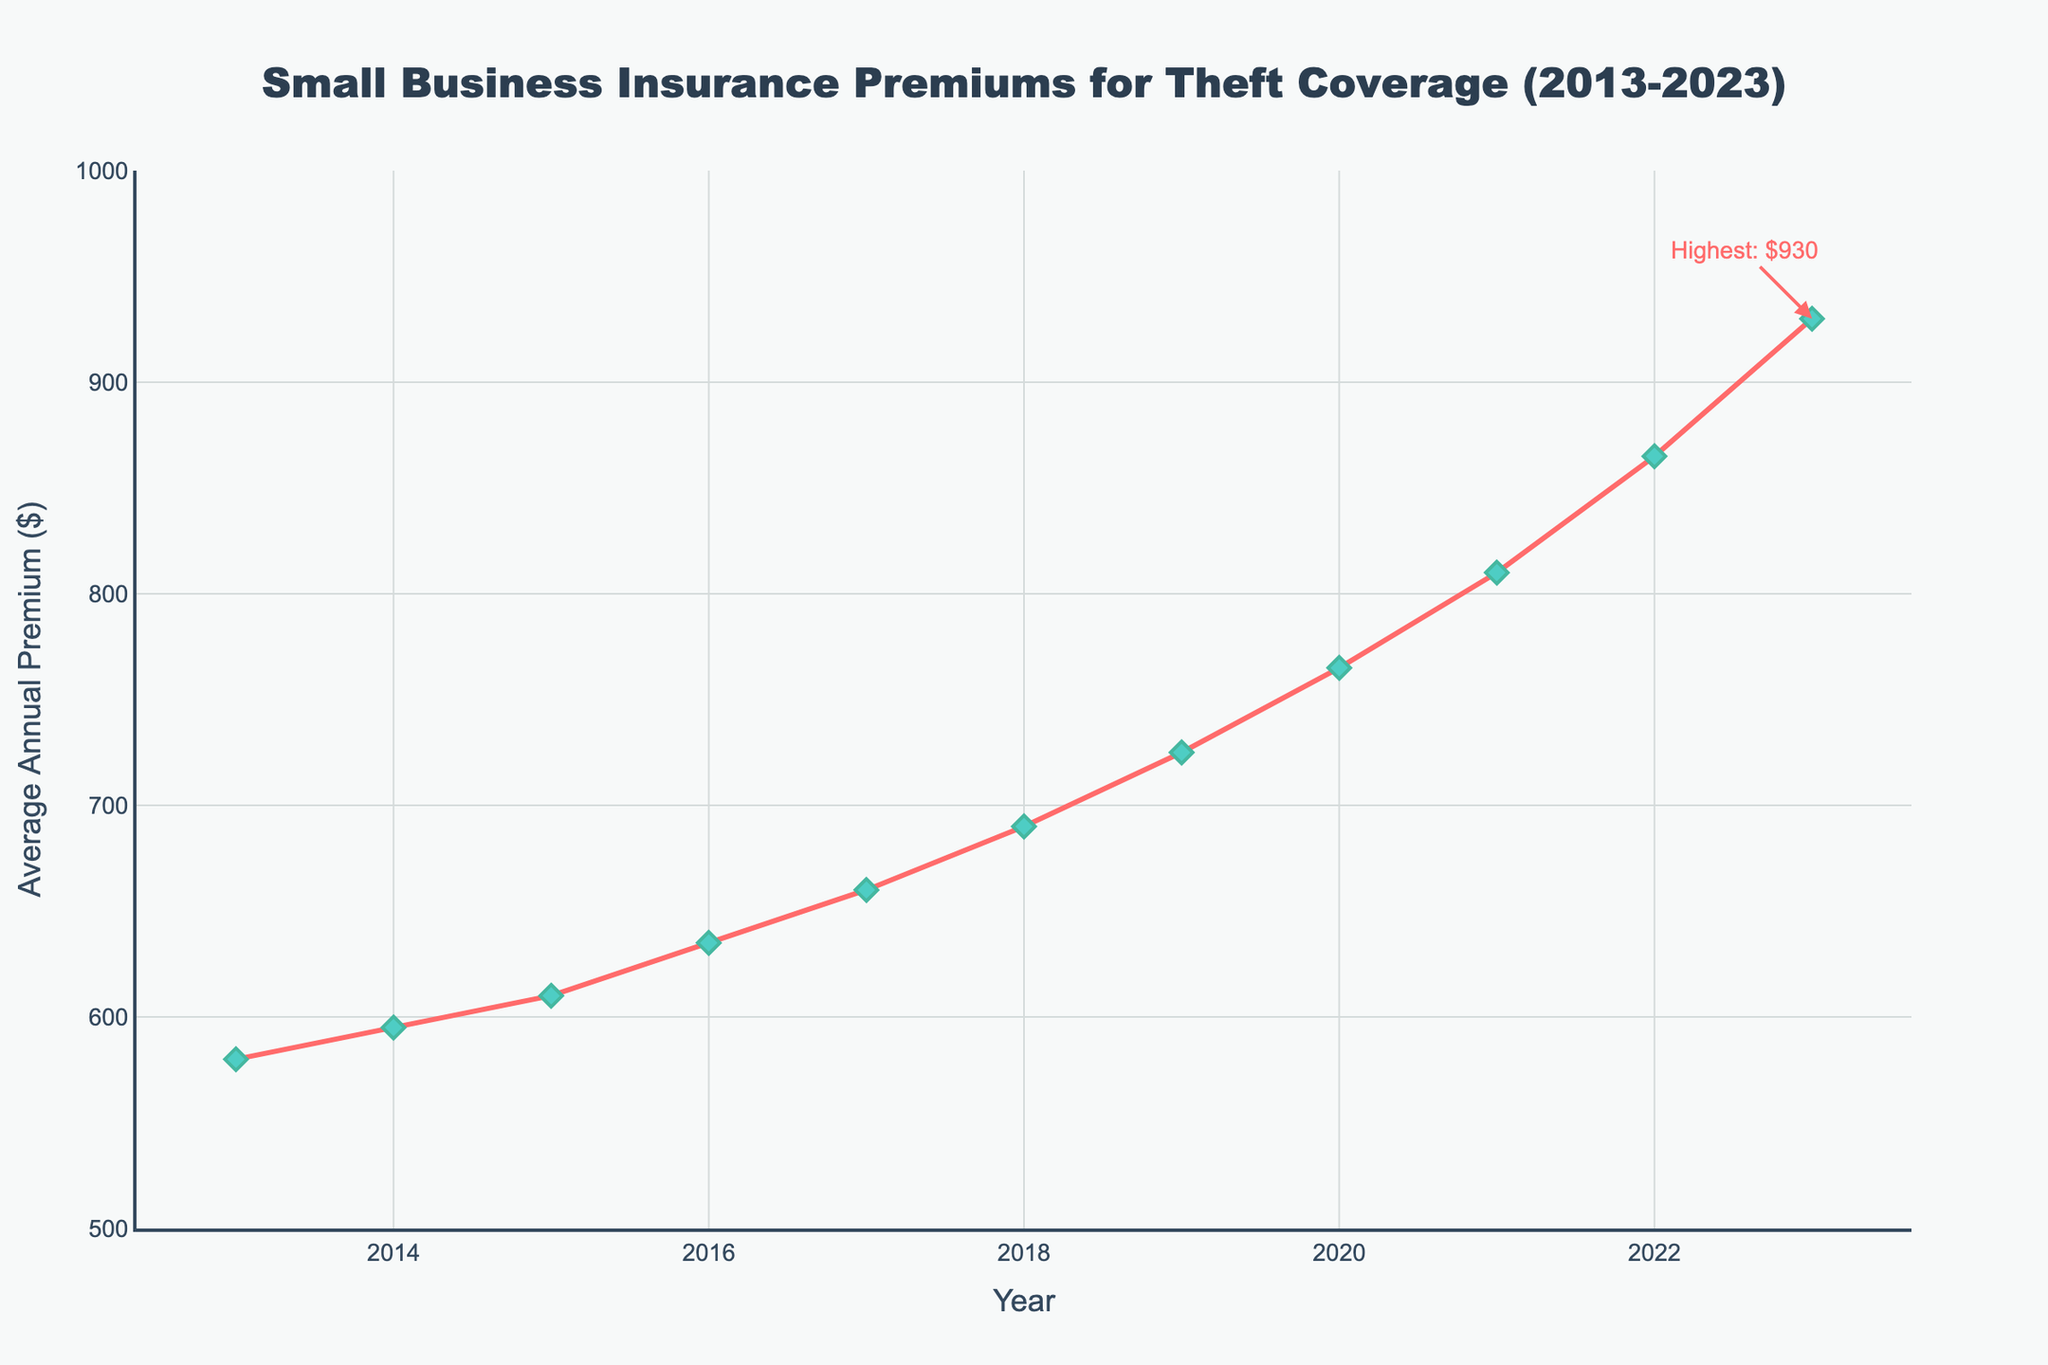What is the trend in the average annual premium for theft coverage over the last decade? Look at the overall pattern of the line from 2013 to 2023. The line rises consistently each year, showing an increasing trend in the average annual premium for theft coverage.
Answer: Increasing Which year had the highest average annual premium for theft coverage? Look at the end of the line chart and locate the highest point, marked with "Highest: $930." This point corresponds to the year 2023.
Answer: 2023 How much did the average annual premium increase from 2013 to 2023? Find the premium value for 2013 ($580) and for 2023 ($930), then subtract the 2013 value from the 2023 value. 930 - 580 = 350.
Answer: $350 Between which consecutive years did the average annual premium for theft coverage increase the most? Look at the gaps between consecutive points along the line and note that the largest increase occurs between 2022 ($865) and 2023 ($930). The difference is 930 - 865 = 65.
Answer: 2022-2023 What is the average annual premium for the year 2019? Identify the point on the line for the year 2019 and read its value, which is $725.
Answer: $725 Has there been any year where the premium did not increase compared to the previous year? Scan each point and note the value of the premium. Each consecutive year shows an increase compared to the previous year.
Answer: No By how much did the average annual premium increase from 2018 to 2019? Locate the premium values for 2018 ($690) and 2019 ($725), then subtract the 2018 value from the 2019 value. 725 - 690 = 35.
Answer: $35 Which year experienced a $55 increase in the average annual premium? Check each pair of consecutive years and find where the premium increased by $55. This happens between 2021 ($810) and 2022 ($865).
Answer: 2021-2022 What color are the data points on the line chart? Observe the color of the markers on the line. They are described as green in the code, which translates to their visual appearance.
Answer: Green In which years did the average annual premium exceed $700 for the first time? Locate the points on the line and note that the premium first exceeds $700 in 2019, where the value is $725.
Answer: 2019 